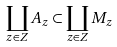Convert formula to latex. <formula><loc_0><loc_0><loc_500><loc_500>\coprod _ { z \in Z } A _ { z } \subset \coprod _ { z \in Z } M _ { z }</formula> 